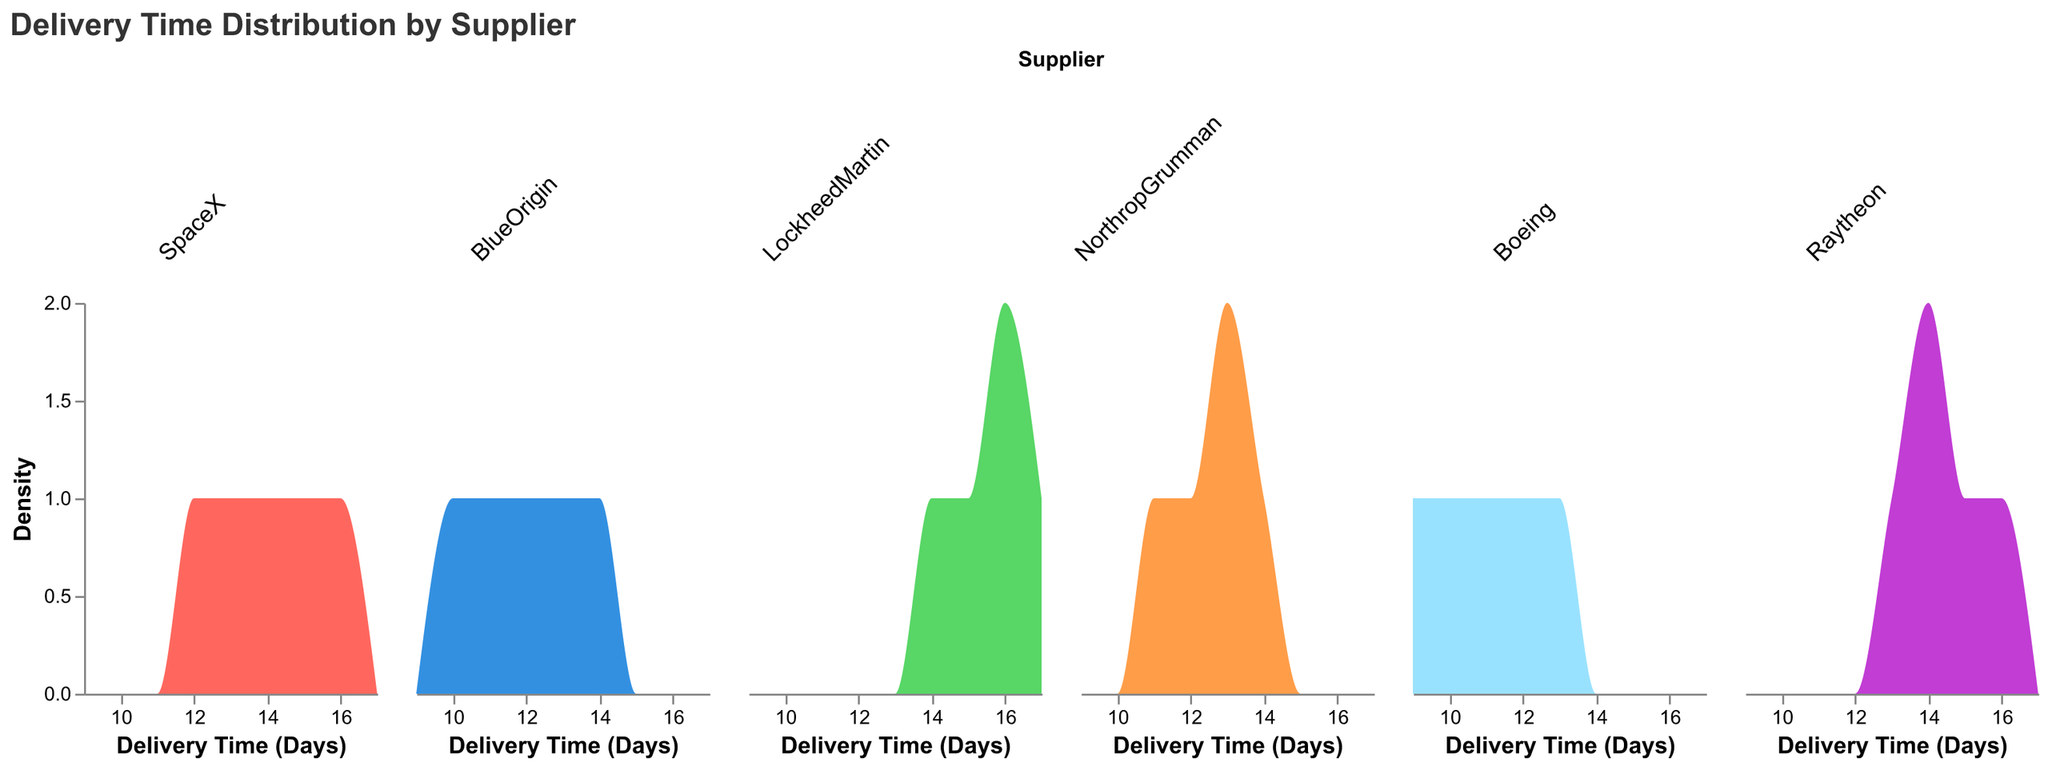What is the title of the figure? The title of the figure is displayed at the top and typically in a larger and bolder font. Here, the title is "Delivery Time Distribution by Supplier".
Answer: Delivery Time Distribution by Supplier What is the delivery time range for deliveries from SpaceX? The delivery time range is determined by observing the x-axis span specific to SpaceX in the subplot. For SpaceX, the delivery times range from 12 to 16 days.
Answer: 12 to 16 days Which supplier has the lowest delivery time observed? To find the supplier with the lowest delivery time, look for the smallest delivery time value across all subplots. Boeing has the lowest delivery time of 9 days.
Answer: Boeing Which supplier has the most variable delivery times? The variability in delivery times can be inferred by looking at the spread or width of the density curves in each supplier's subplot. LockheedMartin and Raytheon show the widest spreads indicating higher variability.
Answer: LockheedMartin What is the most frequent delivery time for BlueOrigin? The most frequent delivery time is indicated by the peak of the density curve. For BlueOrigin, this peak occurs at 12 and 13 days.
Answer: 12 and 13 days What is the approximate average delivery time for NorthropGrumman? The approximate average can be estimated by looking at the central tendency of the density curve of NorthropGrumman. The curve peaks around 13 days.
Answer: ~13 days Is there any supplier with a delivery time exactly equal to 17 days? By examining the subplots, we see that LockheedMartin has a delivery time that extends to 17 days.
Answer: Yes, LockheedMartin Compare the density curves of SpaceX and Boeing, which supplier tends to have shorter delivery times? SpaceX's delivery times range from 12 to 16 days, while Boeing's range from 9 to 13 days. By comparing the density curves, Boeing's delivery times are generally shorter.
Answer: Boeing What is the range of delivery times for Raytheon? Raytheon's density curve spans from 13 to 16 days, thus indicating its delivery time range.
Answer: 13 to 16 days 